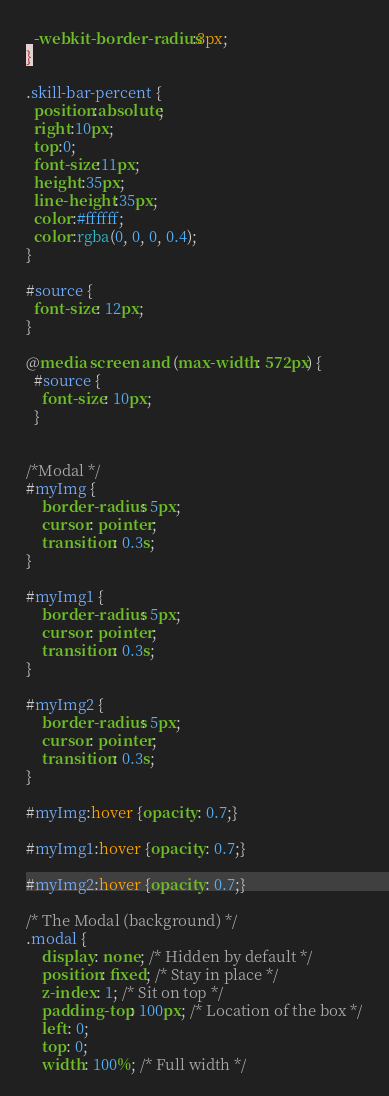<code> <loc_0><loc_0><loc_500><loc_500><_CSS_>  -webkit-border-radius:3px;
}

.skill-bar-percent {
  position:absolute;
  right:10px;
  top:0;
  font-size:11px;
  height:35px;
  line-height:35px;
  color:#ffffff;
  color:rgba(0, 0, 0, 0.4);
}

#source {
  font-size: 12px;
}

@media screen and (max-width: 572px) {
  #source {
    font-size: 10px;
  }


/*Modal */
#myImg {
    border-radius: 5px;
    cursor: pointer;
    transition: 0.3s;
}

#myImg1 {
    border-radius: 5px;
    cursor: pointer;
    transition: 0.3s;
}

#myImg2 {
    border-radius: 5px;
    cursor: pointer;
    transition: 0.3s;
}

#myImg:hover {opacity: 0.7;}

#myImg1:hover {opacity: 0.7;}

#myImg2:hover {opacity: 0.7;}

/* The Modal (background) */
.modal {
    display: none; /* Hidden by default */
    position: fixed; /* Stay in place */
    z-index: 1; /* Sit on top */
    padding-top: 100px; /* Location of the box */
    left: 0;
    top: 0;
    width: 100%; /* Full width */</code> 